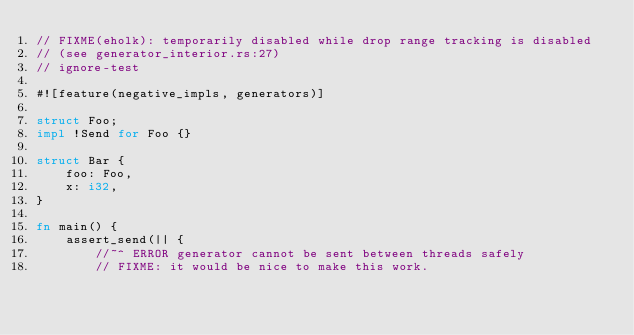Convert code to text. <code><loc_0><loc_0><loc_500><loc_500><_Rust_>// FIXME(eholk): temporarily disabled while drop range tracking is disabled
// (see generator_interior.rs:27)
// ignore-test

#![feature(negative_impls, generators)]

struct Foo;
impl !Send for Foo {}

struct Bar {
    foo: Foo,
    x: i32,
}

fn main() {
    assert_send(|| {
        //~^ ERROR generator cannot be sent between threads safely
        // FIXME: it would be nice to make this work.</code> 